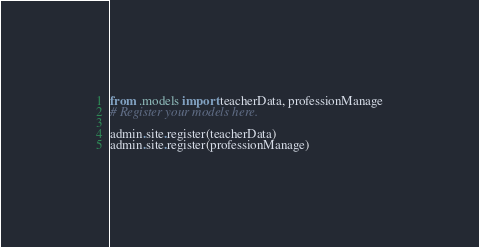Convert code to text. <code><loc_0><loc_0><loc_500><loc_500><_Python_>from .models import teacherData, professionManage
# Register your models here.

admin.site.register(teacherData)
admin.site.register(professionManage)</code> 